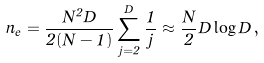<formula> <loc_0><loc_0><loc_500><loc_500>n _ { e } = \frac { N ^ { 2 } D } { 2 ( N - 1 ) } \sum _ { j = 2 } ^ { D } \frac { 1 } { j } \approx \frac { N } { 2 } D \log D \, ,</formula> 